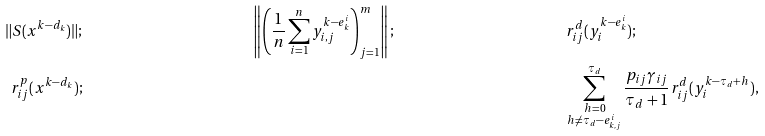<formula> <loc_0><loc_0><loc_500><loc_500>\| S ( x ^ { k - d _ { k } } ) \| ; & & \left \| \left ( \frac { 1 } { n } \sum _ { i = 1 } ^ { n } y _ { i , j } ^ { k - e ^ { i } _ { k } } \right ) _ { j = 1 } ^ { m } \right \| ; & & & r _ { i j } ^ { d } ( y _ { i } ^ { k - e ^ { i } _ { k } } ) ; \\ r _ { i j } ^ { p } ( x ^ { k - d _ { k } } ) ; & & & & & \sum _ { \substack { h = 0 \\ h \neq \tau _ { d } - e ^ { i } _ { k , j } } } ^ { \tau _ { d } } \frac { p _ { i j } \gamma _ { i j } } { \tau _ { d } + 1 } r _ { i j } ^ { d } ( y _ { i } ^ { k - \tau _ { d } + h } ) ,</formula> 